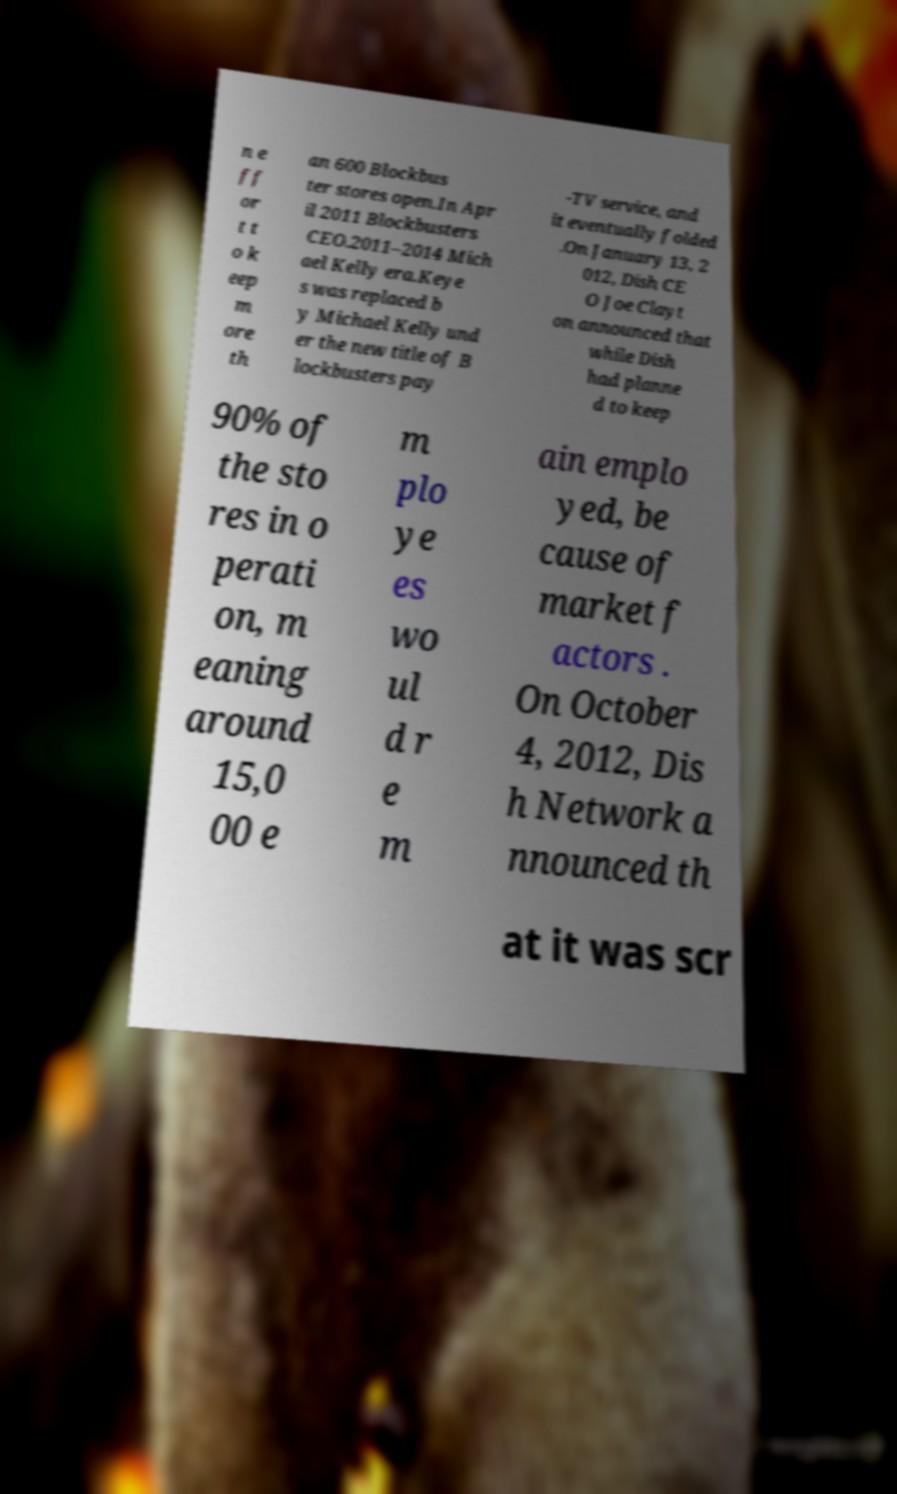Can you read and provide the text displayed in the image?This photo seems to have some interesting text. Can you extract and type it out for me? n e ff or t t o k eep m ore th an 600 Blockbus ter stores open.In Apr il 2011 Blockbusters CEO.2011–2014 Mich ael Kelly era.Keye s was replaced b y Michael Kelly und er the new title of B lockbusters pay -TV service, and it eventually folded .On January 13, 2 012, Dish CE O Joe Clayt on announced that while Dish had planne d to keep 90% of the sto res in o perati on, m eaning around 15,0 00 e m plo ye es wo ul d r e m ain emplo yed, be cause of market f actors . On October 4, 2012, Dis h Network a nnounced th at it was scr 